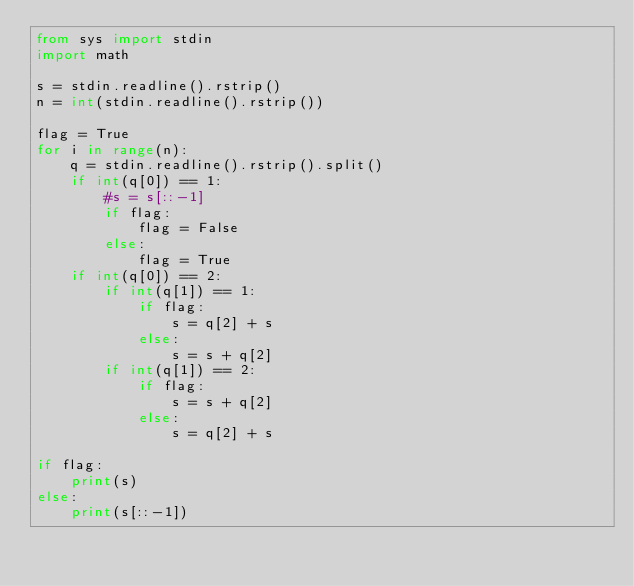<code> <loc_0><loc_0><loc_500><loc_500><_Python_>from sys import stdin
import math

s = stdin.readline().rstrip()
n = int(stdin.readline().rstrip())

flag = True
for i in range(n):
    q = stdin.readline().rstrip().split()
    if int(q[0]) == 1:
        #s = s[::-1]
        if flag:
            flag = False
        else:
            flag = True
    if int(q[0]) == 2:
        if int(q[1]) == 1:
            if flag:
                s = q[2] + s
            else:
                s = s + q[2]
        if int(q[1]) == 2:
            if flag:
                s = s + q[2]
            else:
                s = q[2] + s

if flag:   
    print(s)
else:
    print(s[::-1])</code> 